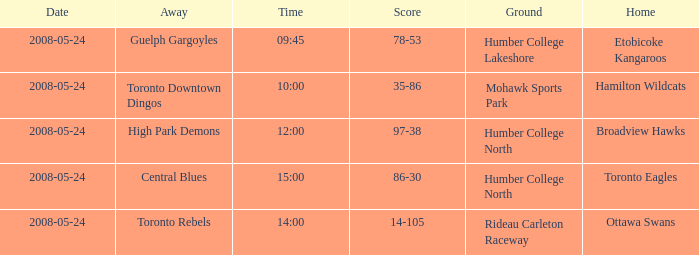Who was the home team of the game at the time of 14:00? Ottawa Swans. 